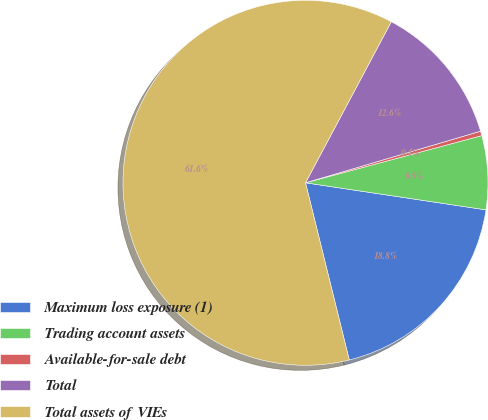Convert chart. <chart><loc_0><loc_0><loc_500><loc_500><pie_chart><fcel>Maximum loss exposure (1)<fcel>Trading account assets<fcel>Available-for-sale debt<fcel>Total<fcel>Total assets of VIEs<nl><fcel>18.78%<fcel>6.53%<fcel>0.4%<fcel>12.65%<fcel>61.65%<nl></chart> 